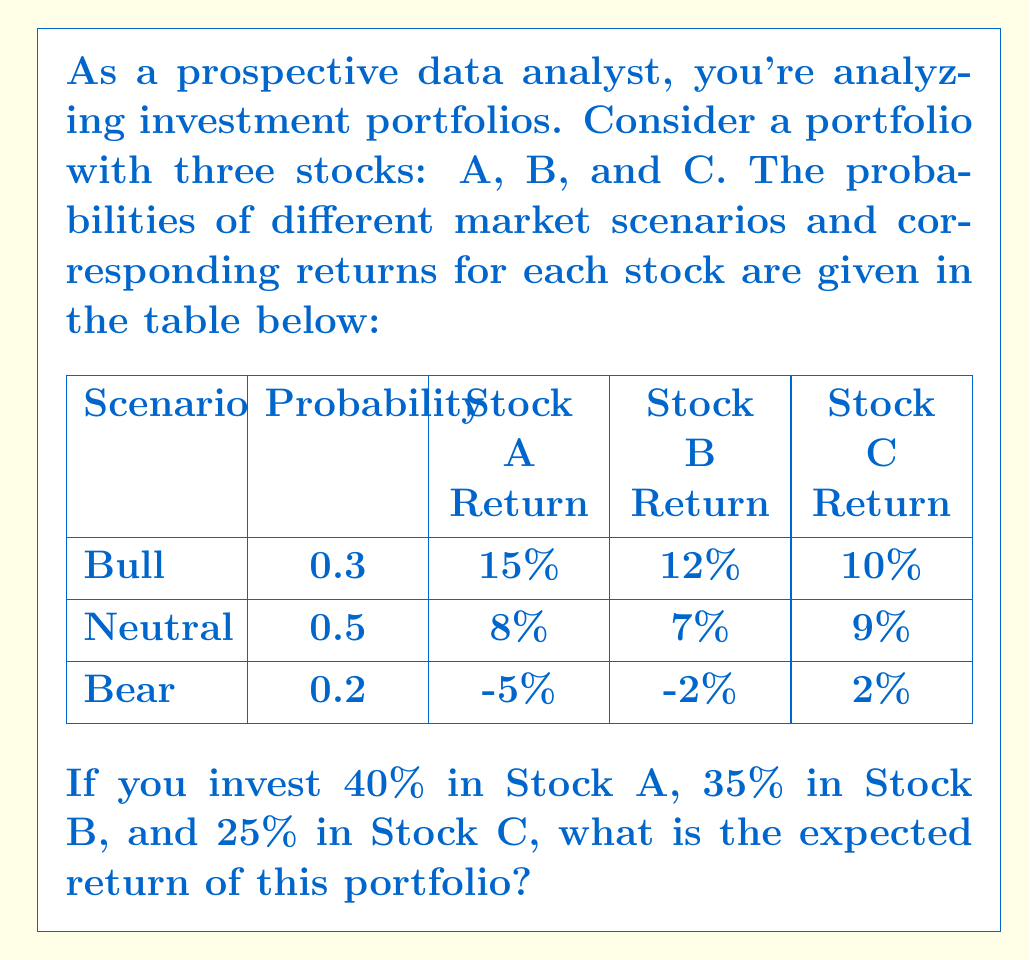Can you solve this math problem? To solve this problem, we need to calculate the expected value of the portfolio's return. Let's break it down step-by-step:

1. Calculate the expected return for each stock:

   For Stock A:
   $E(A) = 0.3 \times 15\% + 0.5 \times 8\% + 0.2 \times (-5\%) = 7.5\%$

   For Stock B:
   $E(B) = 0.3 \times 12\% + 0.5 \times 7\% + 0.2 \times (-2\%) = 6.6\%$

   For Stock C:
   $E(C) = 0.3 \times 10\% + 0.5 \times 9\% + 0.2 \times 2\% = 7.9\%$

2. Calculate the weighted expected return for each stock based on the portfolio allocation:

   Stock A: $40\% \times 7.5\% = 3\%$
   Stock B: $35\% \times 6.6\% = 2.31\%$
   Stock C: $25\% \times 7.9\% = 1.975\%$

3. Sum up the weighted expected returns to get the portfolio's expected return:

   $E(\text{Portfolio}) = 3\% + 2.31\% + 1.975\% = 7.285\%$

Therefore, the expected return of the portfolio is 7.285%.
Answer: 7.285% 